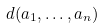<formula> <loc_0><loc_0><loc_500><loc_500>d ( a _ { 1 } , \dots , a _ { n } )</formula> 